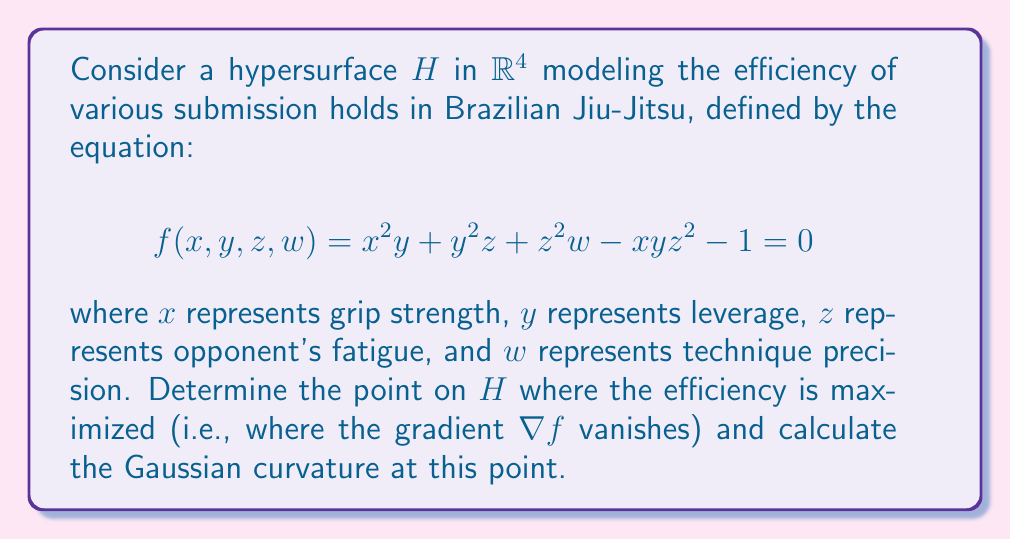Solve this math problem. 1) To find the point where efficiency is maximized, we need to solve $\nabla f = 0$:

   $$\frac{\partial f}{\partial x} = 2xy - yz^2 = 0$$
   $$\frac{\partial f}{\partial y} = x^2 + 2yz - xz^2 = 0$$
   $$\frac{\partial f}{\partial z} = y^2 + 2zw - 2xyz = 0$$
   $$\frac{\partial f}{\partial w} = z^2 = 0$$

2) From $\frac{\partial f}{\partial w} = 0$, we get $z = 0$. Substituting this into the other equations:

   $$2xy = 0$$
   $$x^2 = 0$$
   $$y^2 + 0 = 0$$

3) This gives us $x = y = z = 0$. Substituting these values into the original equation:

   $$0 + 0 + 0 - 0 - 1 = 0$$
   $$w = 1$$

4) Therefore, the point of maximum efficiency is $(0, 0, 0, 1)$.

5) To calculate the Gaussian curvature, we need to compute the Hessian matrix at this point:

   $$H = \begin{bmatrix}
   0 & 2 & 0 & 0 \\
   2 & 0 & 0 & 0 \\
   0 & 0 & 2 & 0 \\
   0 & 0 & 0 & 0
   \end{bmatrix}$$

6) The Gaussian curvature is given by the determinant of the Hessian divided by $(1 + |\nabla f|^2)^2$. At $(0,0,0,1)$, $|\nabla f|^2 = 0$, so:

   $$K = \det(H) = 0$$

Therefore, the Gaussian curvature at the point of maximum efficiency is 0.
Answer: Maximum efficiency point: $(0,0,0,1)$; Gaussian curvature: 0 